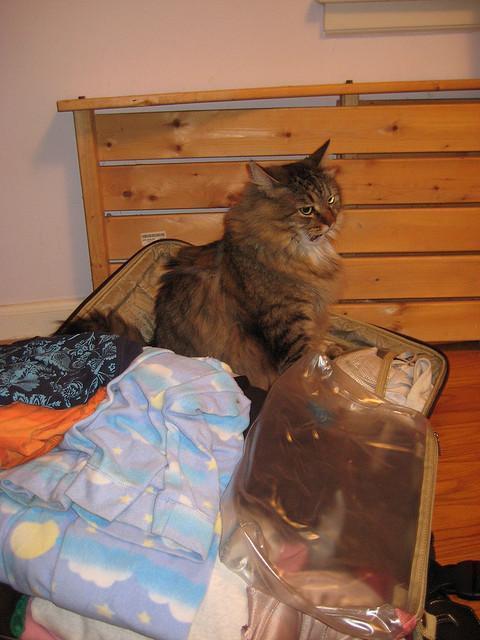How many cats are there?
Give a very brief answer. 1. 